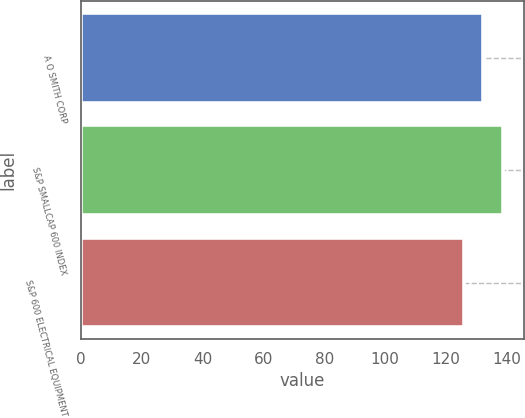<chart> <loc_0><loc_0><loc_500><loc_500><bar_chart><fcel>A O SMITH CORP<fcel>S&P SMALLCAP 600 INDEX<fcel>S&P 600 ELECTRICAL EQUIPMENT<nl><fcel>132.23<fcel>138.79<fcel>126.12<nl></chart> 